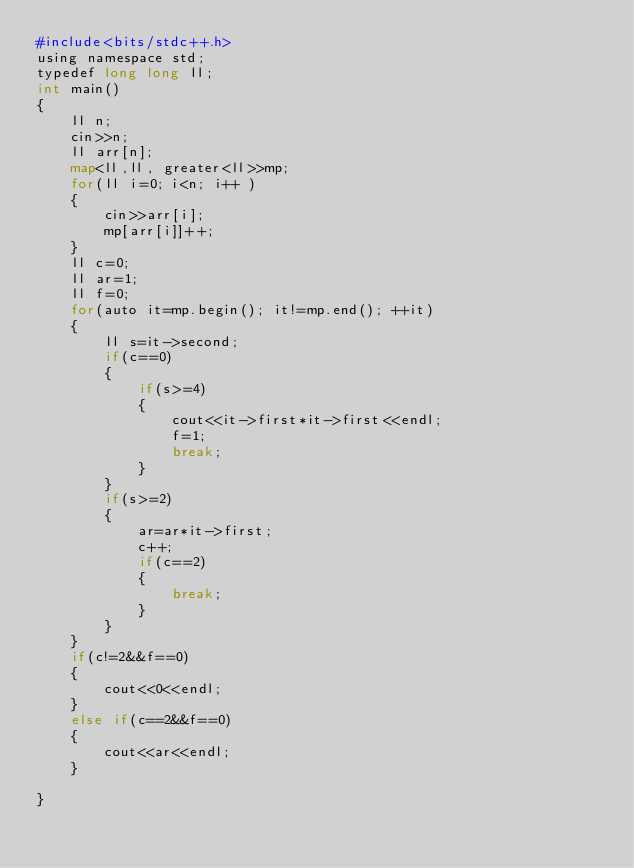Convert code to text. <code><loc_0><loc_0><loc_500><loc_500><_Python_>#include<bits/stdc++.h>
using namespace std;
typedef long long ll;
int main()
{
    ll n;
    cin>>n;
    ll arr[n];
    map<ll,ll, greater<ll>>mp;
    for(ll i=0; i<n; i++ )
    {
        cin>>arr[i];
        mp[arr[i]]++;
    }
    ll c=0;
    ll ar=1;
    ll f=0;
    for(auto it=mp.begin(); it!=mp.end(); ++it)
    {
        ll s=it->second;
        if(c==0)
        {
            if(s>=4)
            {
                cout<<it->first*it->first<<endl;
                f=1;
                break;
            }
        }
        if(s>=2)
        {
            ar=ar*it->first;
            c++;
            if(c==2)
            {
                break;
            }
        }
    }
    if(c!=2&&f==0)
    {
        cout<<0<<endl;
    }
    else if(c==2&&f==0)
    {
        cout<<ar<<endl;
    }

}
</code> 